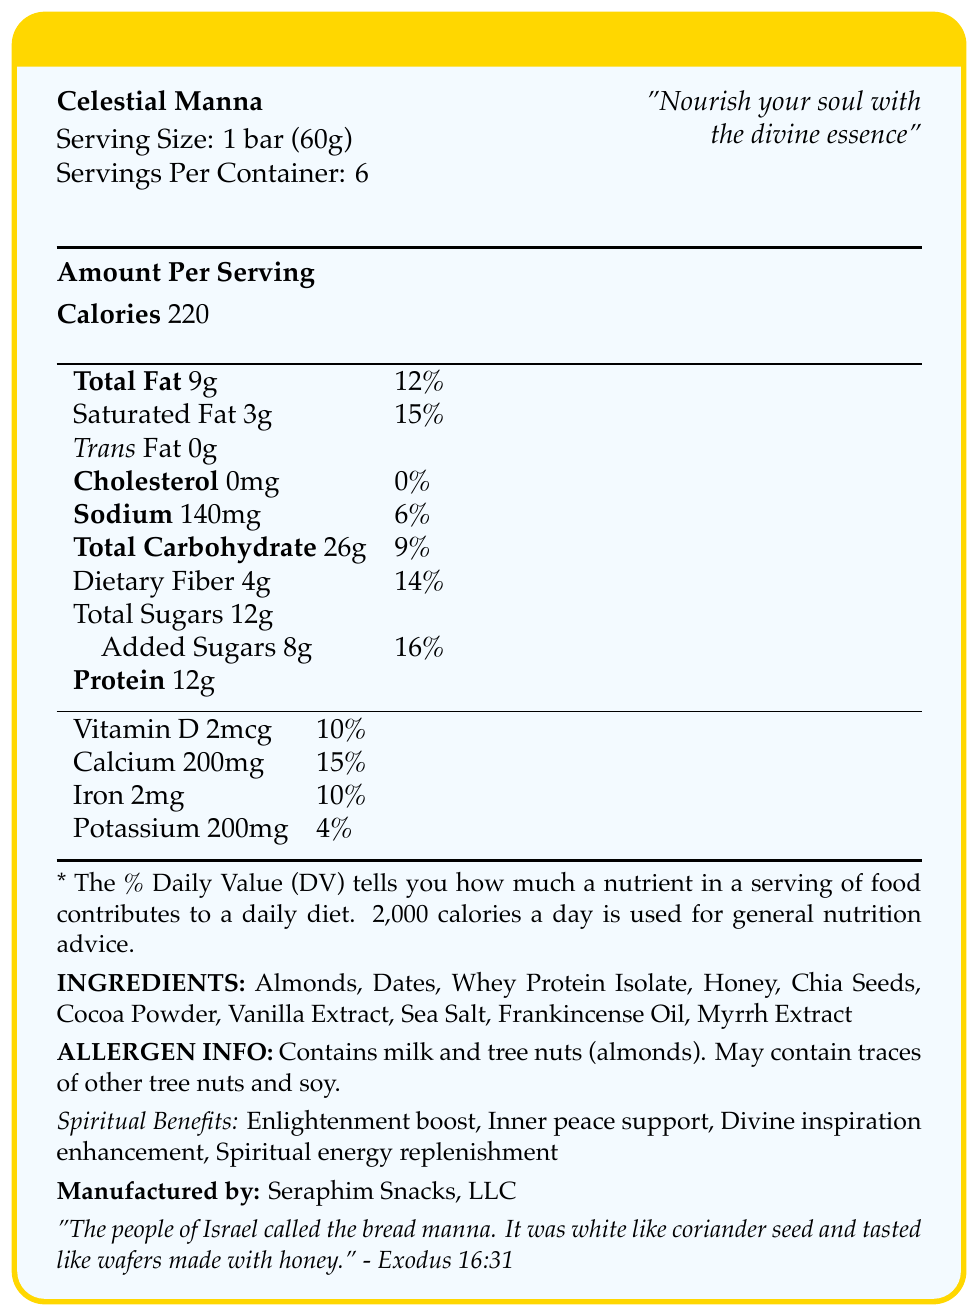what is the serving size of Celestial Manna? This information is listed under the "Serving Size" section.
Answer: 1 bar (60g) how many servings are there per container? This information is listed under the "Servings Per Container" section.
Answer: 6 how many total calories are in one serving? This is listed under the "Calories" section.
Answer: 220 what are the two biblical ingredients included in the nutrition bars? These ingredients are mentioned in the "INGREDIENTS" section.
Answer: Frankincense Oil and Myrrh Extract what amount of protein is contained in one serving? This is listed under the "Protein" section.
Answer: 12g what percentage of daily value (DV) is the total fat per serving? This information is listed under the "Total Fat" section.
Answer: 12% how much added sugars are there in one serving? This is listed under the "Added Sugars" section.
Answer: 8g how much calcium does one bar contain? A. 100mg B. 150mg C. 200mg D. 50mg This information is listed under the "Calcium" section.
Answer: C. 200mg what is the biblical reference associated with Celestial Manna? A. Proverbs 3:5 B. Genesis 1:1 C. Exodus 16:31 D. Psalms 23:1 This reference is listed under the biblical quote near the end of the document.
Answer: C. Exodus 16:31 does Celestial Manna contain any trans fat? The document states "Trans Fat 0g" under the relevant section.
Answer: No is whey protein isolate listed as an ingredient in Celestial Manna? This is listed among the ingredients.
Answer: Yes summarize the main idea of the document. The document provides a detailed description of the product along with its nutritional content, ingredients, allergen warnings, and spiritual benefits.
Answer: Celestial Manna is a protein bar designed with spiritual and nutritional benefits in mind, featuring a poetic description, a list of ingredients (including some biblically inspired ones), nutritional information per serving, allergen information, and suggested spiritual benefits. The label includes a biblical reference and is produced by Seraphim Snacks, LLC. what is the poetic description mentioned in the document? This is quoted in the section titled "poetic_description".
Answer: "Nourish your soul with the divine essence of Celestial Manna, a protein bar infused with the flavors of paradise. Each bite is a communion with the heavens, blending earthly sustenance with spiritual delight." who is the manufacturer of Celestial Manna? This information is listed under the "Manufactured by" section.
Answer: Seraphim Snacks, LLC how much dietary fiber is in one serving of Celestial Manna, and what percentage of the daily value does it constitute? Both the amount and the percentage are listed under the "Dietary Fiber" section.
Answer: 4g, 14% what spiritual benefits are claimed by consuming Celestial Manna? These are listed under the "Spiritual Benefits" section.
Answer: Enlightenment boost, Inner peace support, Divine inspiration enhancement, Spiritual energy replenishment does the document state the exact price of Celestial Manna? The document provides detailed nutritional and spiritual information but does not mention the price.
Answer: Not enough information what is the daily value percentage for iron per serving of Celestial Manna? A. 5% B. 10% C. 15% D. 20% This percentage is listed under the "Iron" section.
Answer: B. 10% 